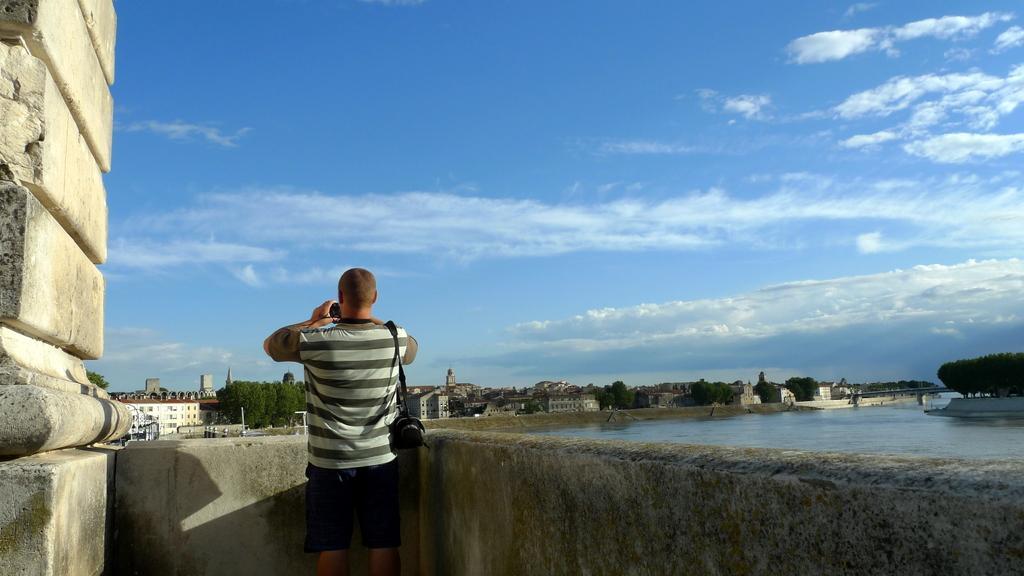Can you describe this image briefly? In the foreground of the picture there is a person holding camera, beside him there is a pillar, in front of him there is a wall. In the center of the picture there are trees, buildings and water body. Sky is sunny. 